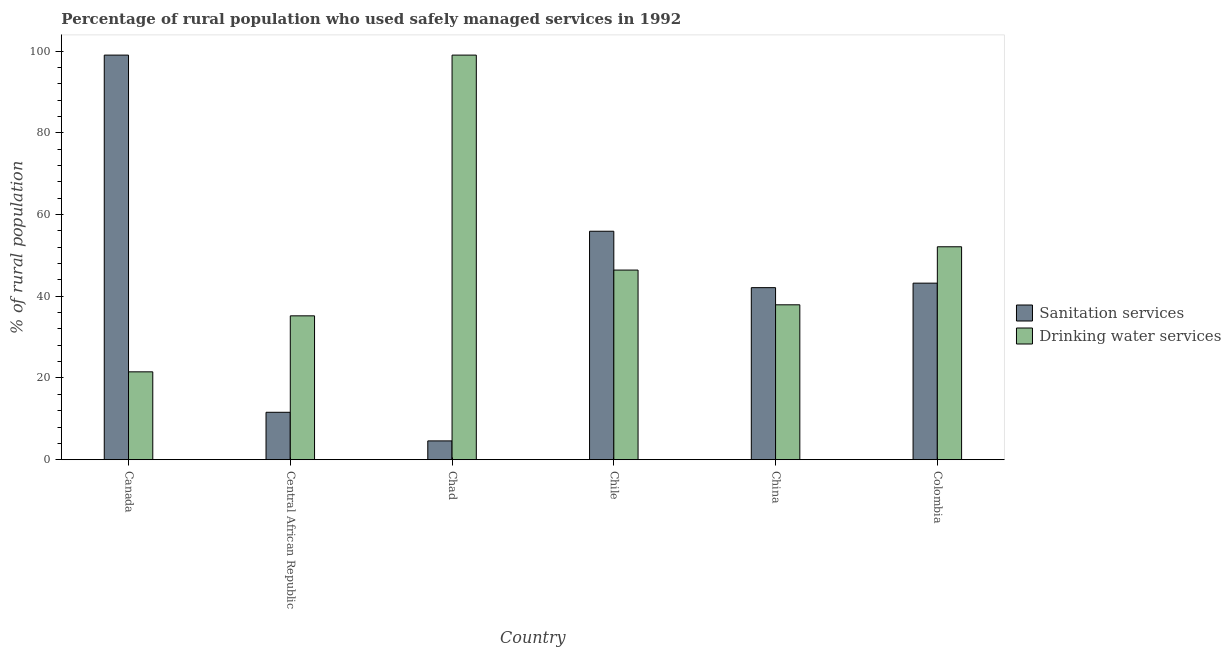How many different coloured bars are there?
Keep it short and to the point. 2. How many groups of bars are there?
Ensure brevity in your answer.  6. Are the number of bars on each tick of the X-axis equal?
Keep it short and to the point. Yes. What is the label of the 3rd group of bars from the left?
Provide a short and direct response. Chad. In how many cases, is the number of bars for a given country not equal to the number of legend labels?
Provide a short and direct response. 0. What is the percentage of rural population who used sanitation services in China?
Keep it short and to the point. 42.1. Across all countries, what is the maximum percentage of rural population who used drinking water services?
Offer a terse response. 99. Across all countries, what is the minimum percentage of rural population who used drinking water services?
Make the answer very short. 21.5. In which country was the percentage of rural population who used drinking water services maximum?
Your answer should be compact. Chad. In which country was the percentage of rural population who used sanitation services minimum?
Your response must be concise. Chad. What is the total percentage of rural population who used sanitation services in the graph?
Give a very brief answer. 256.4. What is the difference between the percentage of rural population who used drinking water services in Canada and that in Colombia?
Offer a terse response. -30.6. What is the difference between the percentage of rural population who used drinking water services in China and the percentage of rural population who used sanitation services in Colombia?
Offer a terse response. -5.3. What is the average percentage of rural population who used sanitation services per country?
Provide a succinct answer. 42.73. In how many countries, is the percentage of rural population who used drinking water services greater than 72 %?
Ensure brevity in your answer.  1. What is the ratio of the percentage of rural population who used sanitation services in China to that in Colombia?
Provide a succinct answer. 0.97. Is the percentage of rural population who used drinking water services in Canada less than that in Chad?
Provide a succinct answer. Yes. What is the difference between the highest and the second highest percentage of rural population who used sanitation services?
Keep it short and to the point. 43.1. What is the difference between the highest and the lowest percentage of rural population who used drinking water services?
Give a very brief answer. 77.5. What does the 2nd bar from the left in Chile represents?
Offer a terse response. Drinking water services. What does the 1st bar from the right in China represents?
Make the answer very short. Drinking water services. How many bars are there?
Provide a succinct answer. 12. Are all the bars in the graph horizontal?
Provide a short and direct response. No. How many countries are there in the graph?
Your answer should be compact. 6. What is the difference between two consecutive major ticks on the Y-axis?
Provide a succinct answer. 20. Does the graph contain grids?
Your response must be concise. No. How are the legend labels stacked?
Your response must be concise. Vertical. What is the title of the graph?
Give a very brief answer. Percentage of rural population who used safely managed services in 1992. What is the label or title of the Y-axis?
Your answer should be compact. % of rural population. What is the % of rural population of Drinking water services in Central African Republic?
Your answer should be compact. 35.2. What is the % of rural population of Sanitation services in Chad?
Give a very brief answer. 4.6. What is the % of rural population in Drinking water services in Chad?
Ensure brevity in your answer.  99. What is the % of rural population of Sanitation services in Chile?
Keep it short and to the point. 55.9. What is the % of rural population of Drinking water services in Chile?
Offer a very short reply. 46.4. What is the % of rural population in Sanitation services in China?
Your answer should be very brief. 42.1. What is the % of rural population in Drinking water services in China?
Offer a terse response. 37.9. What is the % of rural population of Sanitation services in Colombia?
Provide a short and direct response. 43.2. What is the % of rural population in Drinking water services in Colombia?
Offer a very short reply. 52.1. Across all countries, what is the maximum % of rural population in Sanitation services?
Provide a succinct answer. 99. Across all countries, what is the maximum % of rural population of Drinking water services?
Offer a terse response. 99. What is the total % of rural population of Sanitation services in the graph?
Make the answer very short. 256.4. What is the total % of rural population in Drinking water services in the graph?
Ensure brevity in your answer.  292.1. What is the difference between the % of rural population of Sanitation services in Canada and that in Central African Republic?
Ensure brevity in your answer.  87.4. What is the difference between the % of rural population in Drinking water services in Canada and that in Central African Republic?
Offer a very short reply. -13.7. What is the difference between the % of rural population of Sanitation services in Canada and that in Chad?
Ensure brevity in your answer.  94.4. What is the difference between the % of rural population of Drinking water services in Canada and that in Chad?
Make the answer very short. -77.5. What is the difference between the % of rural population in Sanitation services in Canada and that in Chile?
Your response must be concise. 43.1. What is the difference between the % of rural population of Drinking water services in Canada and that in Chile?
Make the answer very short. -24.9. What is the difference between the % of rural population of Sanitation services in Canada and that in China?
Ensure brevity in your answer.  56.9. What is the difference between the % of rural population of Drinking water services in Canada and that in China?
Give a very brief answer. -16.4. What is the difference between the % of rural population of Sanitation services in Canada and that in Colombia?
Make the answer very short. 55.8. What is the difference between the % of rural population in Drinking water services in Canada and that in Colombia?
Make the answer very short. -30.6. What is the difference between the % of rural population in Drinking water services in Central African Republic and that in Chad?
Provide a short and direct response. -63.8. What is the difference between the % of rural population in Sanitation services in Central African Republic and that in Chile?
Make the answer very short. -44.3. What is the difference between the % of rural population of Sanitation services in Central African Republic and that in China?
Your response must be concise. -30.5. What is the difference between the % of rural population in Drinking water services in Central African Republic and that in China?
Offer a very short reply. -2.7. What is the difference between the % of rural population in Sanitation services in Central African Republic and that in Colombia?
Provide a short and direct response. -31.6. What is the difference between the % of rural population in Drinking water services in Central African Republic and that in Colombia?
Ensure brevity in your answer.  -16.9. What is the difference between the % of rural population in Sanitation services in Chad and that in Chile?
Your answer should be compact. -51.3. What is the difference between the % of rural population of Drinking water services in Chad and that in Chile?
Ensure brevity in your answer.  52.6. What is the difference between the % of rural population in Sanitation services in Chad and that in China?
Your answer should be very brief. -37.5. What is the difference between the % of rural population in Drinking water services in Chad and that in China?
Provide a short and direct response. 61.1. What is the difference between the % of rural population of Sanitation services in Chad and that in Colombia?
Offer a terse response. -38.6. What is the difference between the % of rural population in Drinking water services in Chad and that in Colombia?
Your response must be concise. 46.9. What is the difference between the % of rural population of Sanitation services in Chile and that in China?
Provide a short and direct response. 13.8. What is the difference between the % of rural population of Drinking water services in Chile and that in China?
Your answer should be very brief. 8.5. What is the difference between the % of rural population of Drinking water services in Chile and that in Colombia?
Ensure brevity in your answer.  -5.7. What is the difference between the % of rural population of Sanitation services in China and that in Colombia?
Make the answer very short. -1.1. What is the difference between the % of rural population of Drinking water services in China and that in Colombia?
Make the answer very short. -14.2. What is the difference between the % of rural population in Sanitation services in Canada and the % of rural population in Drinking water services in Central African Republic?
Provide a short and direct response. 63.8. What is the difference between the % of rural population of Sanitation services in Canada and the % of rural population of Drinking water services in Chile?
Provide a succinct answer. 52.6. What is the difference between the % of rural population in Sanitation services in Canada and the % of rural population in Drinking water services in China?
Offer a terse response. 61.1. What is the difference between the % of rural population of Sanitation services in Canada and the % of rural population of Drinking water services in Colombia?
Your answer should be very brief. 46.9. What is the difference between the % of rural population of Sanitation services in Central African Republic and the % of rural population of Drinking water services in Chad?
Provide a succinct answer. -87.4. What is the difference between the % of rural population in Sanitation services in Central African Republic and the % of rural population in Drinking water services in Chile?
Your response must be concise. -34.8. What is the difference between the % of rural population of Sanitation services in Central African Republic and the % of rural population of Drinking water services in China?
Your response must be concise. -26.3. What is the difference between the % of rural population in Sanitation services in Central African Republic and the % of rural population in Drinking water services in Colombia?
Provide a short and direct response. -40.5. What is the difference between the % of rural population of Sanitation services in Chad and the % of rural population of Drinking water services in Chile?
Ensure brevity in your answer.  -41.8. What is the difference between the % of rural population in Sanitation services in Chad and the % of rural population in Drinking water services in China?
Give a very brief answer. -33.3. What is the difference between the % of rural population in Sanitation services in Chad and the % of rural population in Drinking water services in Colombia?
Your answer should be very brief. -47.5. What is the difference between the % of rural population in Sanitation services in Chile and the % of rural population in Drinking water services in Colombia?
Provide a short and direct response. 3.8. What is the difference between the % of rural population in Sanitation services in China and the % of rural population in Drinking water services in Colombia?
Make the answer very short. -10. What is the average % of rural population in Sanitation services per country?
Keep it short and to the point. 42.73. What is the average % of rural population in Drinking water services per country?
Offer a very short reply. 48.68. What is the difference between the % of rural population of Sanitation services and % of rural population of Drinking water services in Canada?
Offer a very short reply. 77.5. What is the difference between the % of rural population of Sanitation services and % of rural population of Drinking water services in Central African Republic?
Provide a short and direct response. -23.6. What is the difference between the % of rural population of Sanitation services and % of rural population of Drinking water services in Chad?
Provide a succinct answer. -94.4. What is the ratio of the % of rural population of Sanitation services in Canada to that in Central African Republic?
Make the answer very short. 8.53. What is the ratio of the % of rural population in Drinking water services in Canada to that in Central African Republic?
Make the answer very short. 0.61. What is the ratio of the % of rural population in Sanitation services in Canada to that in Chad?
Make the answer very short. 21.52. What is the ratio of the % of rural population of Drinking water services in Canada to that in Chad?
Give a very brief answer. 0.22. What is the ratio of the % of rural population in Sanitation services in Canada to that in Chile?
Keep it short and to the point. 1.77. What is the ratio of the % of rural population of Drinking water services in Canada to that in Chile?
Your response must be concise. 0.46. What is the ratio of the % of rural population of Sanitation services in Canada to that in China?
Provide a succinct answer. 2.35. What is the ratio of the % of rural population of Drinking water services in Canada to that in China?
Ensure brevity in your answer.  0.57. What is the ratio of the % of rural population of Sanitation services in Canada to that in Colombia?
Your answer should be compact. 2.29. What is the ratio of the % of rural population of Drinking water services in Canada to that in Colombia?
Your answer should be very brief. 0.41. What is the ratio of the % of rural population in Sanitation services in Central African Republic to that in Chad?
Provide a short and direct response. 2.52. What is the ratio of the % of rural population of Drinking water services in Central African Republic to that in Chad?
Keep it short and to the point. 0.36. What is the ratio of the % of rural population in Sanitation services in Central African Republic to that in Chile?
Provide a succinct answer. 0.21. What is the ratio of the % of rural population of Drinking water services in Central African Republic to that in Chile?
Your answer should be very brief. 0.76. What is the ratio of the % of rural population in Sanitation services in Central African Republic to that in China?
Make the answer very short. 0.28. What is the ratio of the % of rural population of Drinking water services in Central African Republic to that in China?
Keep it short and to the point. 0.93. What is the ratio of the % of rural population of Sanitation services in Central African Republic to that in Colombia?
Your answer should be compact. 0.27. What is the ratio of the % of rural population in Drinking water services in Central African Republic to that in Colombia?
Your answer should be compact. 0.68. What is the ratio of the % of rural population of Sanitation services in Chad to that in Chile?
Give a very brief answer. 0.08. What is the ratio of the % of rural population of Drinking water services in Chad to that in Chile?
Offer a terse response. 2.13. What is the ratio of the % of rural population in Sanitation services in Chad to that in China?
Offer a terse response. 0.11. What is the ratio of the % of rural population of Drinking water services in Chad to that in China?
Offer a very short reply. 2.61. What is the ratio of the % of rural population of Sanitation services in Chad to that in Colombia?
Offer a terse response. 0.11. What is the ratio of the % of rural population in Drinking water services in Chad to that in Colombia?
Your response must be concise. 1.9. What is the ratio of the % of rural population of Sanitation services in Chile to that in China?
Offer a terse response. 1.33. What is the ratio of the % of rural population in Drinking water services in Chile to that in China?
Offer a very short reply. 1.22. What is the ratio of the % of rural population of Sanitation services in Chile to that in Colombia?
Provide a short and direct response. 1.29. What is the ratio of the % of rural population of Drinking water services in Chile to that in Colombia?
Provide a short and direct response. 0.89. What is the ratio of the % of rural population in Sanitation services in China to that in Colombia?
Provide a succinct answer. 0.97. What is the ratio of the % of rural population in Drinking water services in China to that in Colombia?
Your answer should be compact. 0.73. What is the difference between the highest and the second highest % of rural population of Sanitation services?
Give a very brief answer. 43.1. What is the difference between the highest and the second highest % of rural population in Drinking water services?
Make the answer very short. 46.9. What is the difference between the highest and the lowest % of rural population of Sanitation services?
Provide a succinct answer. 94.4. What is the difference between the highest and the lowest % of rural population of Drinking water services?
Keep it short and to the point. 77.5. 